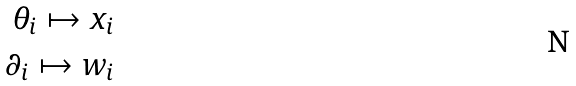Convert formula to latex. <formula><loc_0><loc_0><loc_500><loc_500>\theta _ { i } \mapsto x _ { i } \\ \partial _ { i } \mapsto w _ { i }</formula> 